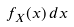<formula> <loc_0><loc_0><loc_500><loc_500>f _ { X } ( x ) \, d x</formula> 